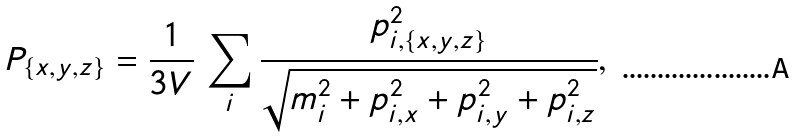<formula> <loc_0><loc_0><loc_500><loc_500>P _ { \{ x , y , z \} } = \frac { 1 } { 3 V } \, \sum _ { i } \frac { p _ { i , \{ x , y , z \} } ^ { 2 } } { \sqrt { m _ { i } ^ { 2 } + p _ { i , x } ^ { 2 } + p _ { i , y } ^ { 2 } + p _ { i , z } ^ { 2 } } } ,</formula> 